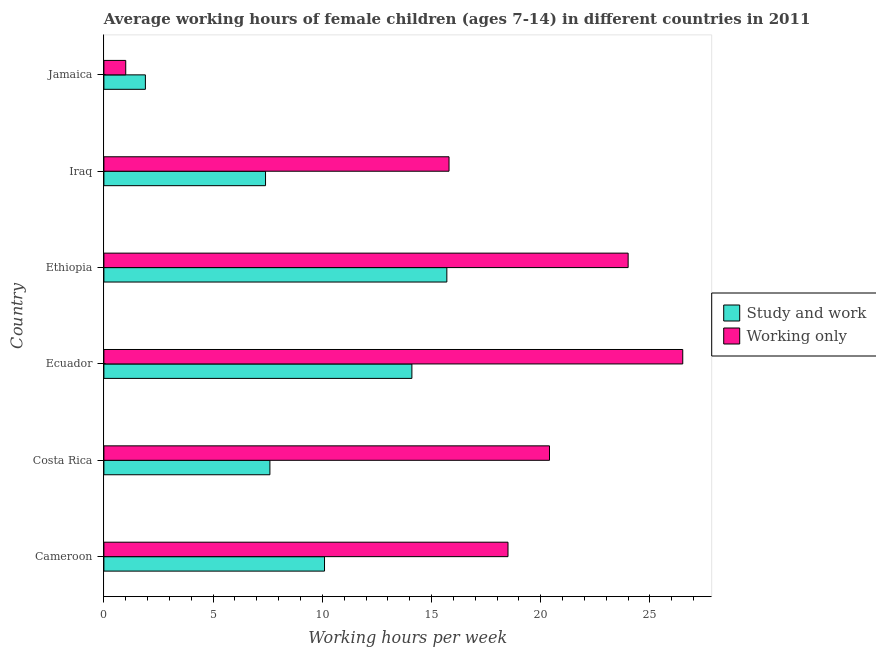How many different coloured bars are there?
Make the answer very short. 2. How many groups of bars are there?
Provide a succinct answer. 6. Are the number of bars per tick equal to the number of legend labels?
Keep it short and to the point. Yes. What is the label of the 2nd group of bars from the top?
Provide a succinct answer. Iraq. What is the average working hour of children involved in only work in Jamaica?
Keep it short and to the point. 1. Across all countries, what is the maximum average working hour of children involved in study and work?
Your answer should be very brief. 15.7. Across all countries, what is the minimum average working hour of children involved in study and work?
Keep it short and to the point. 1.9. In which country was the average working hour of children involved in study and work maximum?
Your answer should be compact. Ethiopia. In which country was the average working hour of children involved in study and work minimum?
Your response must be concise. Jamaica. What is the total average working hour of children involved in study and work in the graph?
Offer a terse response. 56.8. What is the difference between the average working hour of children involved in study and work in Ethiopia and that in Jamaica?
Your answer should be compact. 13.8. What is the difference between the average working hour of children involved in study and work and average working hour of children involved in only work in Costa Rica?
Keep it short and to the point. -12.8. In how many countries, is the average working hour of children involved in study and work greater than 19 hours?
Provide a short and direct response. 0. What is the ratio of the average working hour of children involved in study and work in Ecuador to that in Jamaica?
Your answer should be very brief. 7.42. Is the average working hour of children involved in only work in Ecuador less than that in Iraq?
Provide a short and direct response. No. What is the difference between the highest and the second highest average working hour of children involved in study and work?
Keep it short and to the point. 1.6. What is the difference between the highest and the lowest average working hour of children involved in only work?
Your response must be concise. 25.5. In how many countries, is the average working hour of children involved in study and work greater than the average average working hour of children involved in study and work taken over all countries?
Provide a short and direct response. 3. What does the 2nd bar from the top in Jamaica represents?
Ensure brevity in your answer.  Study and work. What does the 2nd bar from the bottom in Ethiopia represents?
Your answer should be very brief. Working only. Are all the bars in the graph horizontal?
Give a very brief answer. Yes. Does the graph contain any zero values?
Make the answer very short. No. Where does the legend appear in the graph?
Provide a short and direct response. Center right. How many legend labels are there?
Offer a very short reply. 2. What is the title of the graph?
Provide a short and direct response. Average working hours of female children (ages 7-14) in different countries in 2011. What is the label or title of the X-axis?
Your response must be concise. Working hours per week. What is the label or title of the Y-axis?
Make the answer very short. Country. What is the Working hours per week in Study and work in Cameroon?
Offer a very short reply. 10.1. What is the Working hours per week in Working only in Cameroon?
Keep it short and to the point. 18.5. What is the Working hours per week of Working only in Costa Rica?
Provide a succinct answer. 20.4. What is the Working hours per week in Study and work in Ecuador?
Your response must be concise. 14.1. What is the Working hours per week in Working only in Ecuador?
Ensure brevity in your answer.  26.5. What is the Working hours per week of Study and work in Ethiopia?
Your answer should be compact. 15.7. What is the Working hours per week of Study and work in Jamaica?
Give a very brief answer. 1.9. What is the Working hours per week of Working only in Jamaica?
Make the answer very short. 1. Across all countries, what is the maximum Working hours per week in Study and work?
Your response must be concise. 15.7. Across all countries, what is the maximum Working hours per week of Working only?
Offer a terse response. 26.5. Across all countries, what is the minimum Working hours per week of Study and work?
Your response must be concise. 1.9. Across all countries, what is the minimum Working hours per week of Working only?
Your response must be concise. 1. What is the total Working hours per week of Study and work in the graph?
Provide a short and direct response. 56.8. What is the total Working hours per week in Working only in the graph?
Provide a short and direct response. 106.2. What is the difference between the Working hours per week in Study and work in Cameroon and that in Iraq?
Provide a short and direct response. 2.7. What is the difference between the Working hours per week of Study and work in Cameroon and that in Jamaica?
Keep it short and to the point. 8.2. What is the difference between the Working hours per week of Working only in Cameroon and that in Jamaica?
Provide a short and direct response. 17.5. What is the difference between the Working hours per week of Working only in Costa Rica and that in Ecuador?
Ensure brevity in your answer.  -6.1. What is the difference between the Working hours per week of Study and work in Costa Rica and that in Ethiopia?
Your answer should be compact. -8.1. What is the difference between the Working hours per week in Working only in Costa Rica and that in Ethiopia?
Make the answer very short. -3.6. What is the difference between the Working hours per week in Study and work in Costa Rica and that in Jamaica?
Provide a short and direct response. 5.7. What is the difference between the Working hours per week of Study and work in Ecuador and that in Iraq?
Keep it short and to the point. 6.7. What is the difference between the Working hours per week of Working only in Ecuador and that in Iraq?
Your response must be concise. 10.7. What is the difference between the Working hours per week of Working only in Ecuador and that in Jamaica?
Make the answer very short. 25.5. What is the difference between the Working hours per week of Study and work in Ethiopia and that in Iraq?
Ensure brevity in your answer.  8.3. What is the difference between the Working hours per week in Working only in Ethiopia and that in Iraq?
Provide a succinct answer. 8.2. What is the difference between the Working hours per week of Study and work in Ethiopia and that in Jamaica?
Ensure brevity in your answer.  13.8. What is the difference between the Working hours per week of Working only in Ethiopia and that in Jamaica?
Your answer should be compact. 23. What is the difference between the Working hours per week of Study and work in Iraq and that in Jamaica?
Offer a very short reply. 5.5. What is the difference between the Working hours per week in Working only in Iraq and that in Jamaica?
Your answer should be compact. 14.8. What is the difference between the Working hours per week in Study and work in Cameroon and the Working hours per week in Working only in Ecuador?
Your answer should be very brief. -16.4. What is the difference between the Working hours per week of Study and work in Cameroon and the Working hours per week of Working only in Iraq?
Offer a terse response. -5.7. What is the difference between the Working hours per week in Study and work in Cameroon and the Working hours per week in Working only in Jamaica?
Your answer should be compact. 9.1. What is the difference between the Working hours per week of Study and work in Costa Rica and the Working hours per week of Working only in Ecuador?
Your answer should be very brief. -18.9. What is the difference between the Working hours per week of Study and work in Costa Rica and the Working hours per week of Working only in Ethiopia?
Offer a terse response. -16.4. What is the difference between the Working hours per week in Study and work in Ecuador and the Working hours per week in Working only in Jamaica?
Offer a terse response. 13.1. What is the difference between the Working hours per week in Study and work in Ethiopia and the Working hours per week in Working only in Jamaica?
Keep it short and to the point. 14.7. What is the difference between the Working hours per week of Study and work in Iraq and the Working hours per week of Working only in Jamaica?
Your answer should be very brief. 6.4. What is the average Working hours per week of Study and work per country?
Keep it short and to the point. 9.47. What is the average Working hours per week in Working only per country?
Your response must be concise. 17.7. What is the difference between the Working hours per week of Study and work and Working hours per week of Working only in Cameroon?
Your response must be concise. -8.4. What is the difference between the Working hours per week in Study and work and Working hours per week in Working only in Costa Rica?
Provide a short and direct response. -12.8. What is the difference between the Working hours per week of Study and work and Working hours per week of Working only in Ethiopia?
Your answer should be compact. -8.3. What is the difference between the Working hours per week in Study and work and Working hours per week in Working only in Iraq?
Offer a terse response. -8.4. What is the difference between the Working hours per week of Study and work and Working hours per week of Working only in Jamaica?
Make the answer very short. 0.9. What is the ratio of the Working hours per week in Study and work in Cameroon to that in Costa Rica?
Offer a very short reply. 1.33. What is the ratio of the Working hours per week of Working only in Cameroon to that in Costa Rica?
Offer a very short reply. 0.91. What is the ratio of the Working hours per week of Study and work in Cameroon to that in Ecuador?
Ensure brevity in your answer.  0.72. What is the ratio of the Working hours per week in Working only in Cameroon to that in Ecuador?
Your answer should be compact. 0.7. What is the ratio of the Working hours per week in Study and work in Cameroon to that in Ethiopia?
Give a very brief answer. 0.64. What is the ratio of the Working hours per week in Working only in Cameroon to that in Ethiopia?
Your answer should be very brief. 0.77. What is the ratio of the Working hours per week in Study and work in Cameroon to that in Iraq?
Your answer should be compact. 1.36. What is the ratio of the Working hours per week of Working only in Cameroon to that in Iraq?
Your response must be concise. 1.17. What is the ratio of the Working hours per week in Study and work in Cameroon to that in Jamaica?
Your response must be concise. 5.32. What is the ratio of the Working hours per week of Working only in Cameroon to that in Jamaica?
Your answer should be compact. 18.5. What is the ratio of the Working hours per week in Study and work in Costa Rica to that in Ecuador?
Provide a short and direct response. 0.54. What is the ratio of the Working hours per week in Working only in Costa Rica to that in Ecuador?
Your response must be concise. 0.77. What is the ratio of the Working hours per week of Study and work in Costa Rica to that in Ethiopia?
Make the answer very short. 0.48. What is the ratio of the Working hours per week in Working only in Costa Rica to that in Ethiopia?
Provide a short and direct response. 0.85. What is the ratio of the Working hours per week in Working only in Costa Rica to that in Iraq?
Offer a very short reply. 1.29. What is the ratio of the Working hours per week in Study and work in Costa Rica to that in Jamaica?
Keep it short and to the point. 4. What is the ratio of the Working hours per week of Working only in Costa Rica to that in Jamaica?
Give a very brief answer. 20.4. What is the ratio of the Working hours per week of Study and work in Ecuador to that in Ethiopia?
Make the answer very short. 0.9. What is the ratio of the Working hours per week in Working only in Ecuador to that in Ethiopia?
Offer a very short reply. 1.1. What is the ratio of the Working hours per week in Study and work in Ecuador to that in Iraq?
Keep it short and to the point. 1.91. What is the ratio of the Working hours per week in Working only in Ecuador to that in Iraq?
Offer a very short reply. 1.68. What is the ratio of the Working hours per week in Study and work in Ecuador to that in Jamaica?
Your answer should be very brief. 7.42. What is the ratio of the Working hours per week in Study and work in Ethiopia to that in Iraq?
Offer a terse response. 2.12. What is the ratio of the Working hours per week of Working only in Ethiopia to that in Iraq?
Provide a succinct answer. 1.52. What is the ratio of the Working hours per week in Study and work in Ethiopia to that in Jamaica?
Give a very brief answer. 8.26. What is the ratio of the Working hours per week in Study and work in Iraq to that in Jamaica?
Your answer should be compact. 3.89. What is the ratio of the Working hours per week in Working only in Iraq to that in Jamaica?
Offer a very short reply. 15.8. What is the difference between the highest and the second highest Working hours per week in Study and work?
Keep it short and to the point. 1.6. What is the difference between the highest and the lowest Working hours per week of Study and work?
Provide a short and direct response. 13.8. 